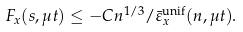Convert formula to latex. <formula><loc_0><loc_0><loc_500><loc_500>F _ { x } ( s , \mu t ) \leq - C n ^ { 1 / 3 } / \bar { \varepsilon } _ { x } ^ { \text {unif} } ( n , \mu t ) .</formula> 